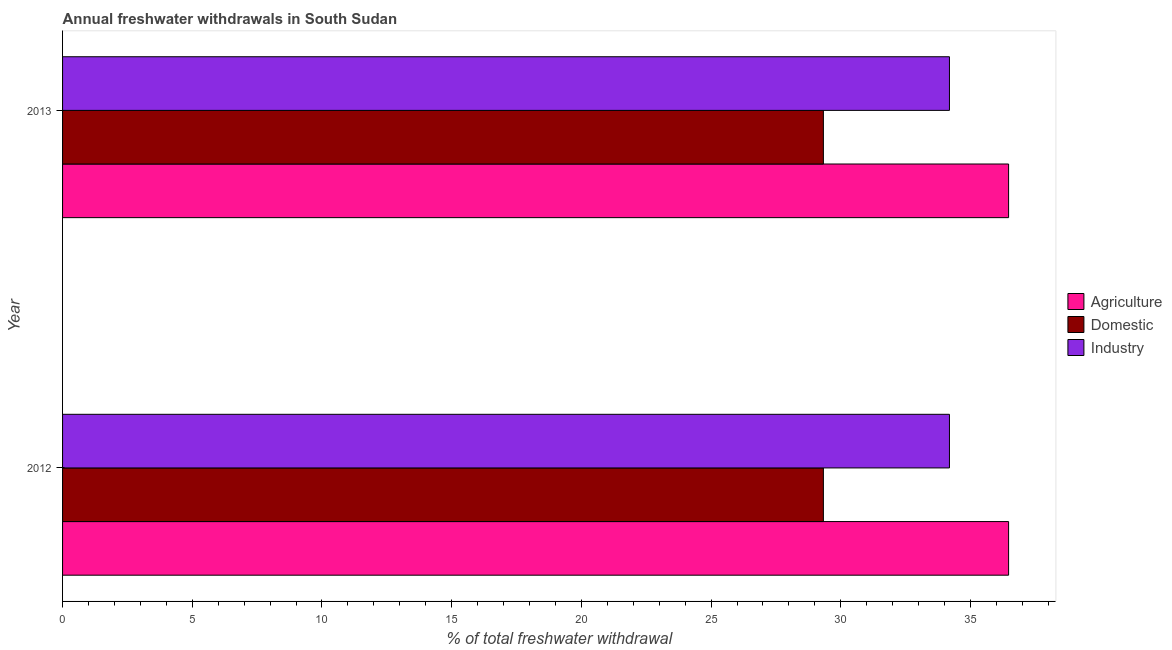How many groups of bars are there?
Offer a very short reply. 2. Are the number of bars per tick equal to the number of legend labels?
Provide a succinct answer. Yes. How many bars are there on the 1st tick from the bottom?
Your response must be concise. 3. What is the percentage of freshwater withdrawal for domestic purposes in 2013?
Make the answer very short. 29.33. Across all years, what is the maximum percentage of freshwater withdrawal for agriculture?
Keep it short and to the point. 36.47. Across all years, what is the minimum percentage of freshwater withdrawal for domestic purposes?
Ensure brevity in your answer.  29.33. What is the total percentage of freshwater withdrawal for industry in the graph?
Your answer should be compact. 68.38. What is the difference between the percentage of freshwater withdrawal for domestic purposes in 2013 and the percentage of freshwater withdrawal for industry in 2012?
Your answer should be very brief. -4.86. What is the average percentage of freshwater withdrawal for agriculture per year?
Provide a short and direct response. 36.47. In the year 2012, what is the difference between the percentage of freshwater withdrawal for domestic purposes and percentage of freshwater withdrawal for industry?
Your answer should be compact. -4.86. In how many years, is the percentage of freshwater withdrawal for domestic purposes greater than 7 %?
Your response must be concise. 2. What is the ratio of the percentage of freshwater withdrawal for agriculture in 2012 to that in 2013?
Your response must be concise. 1. Is the difference between the percentage of freshwater withdrawal for agriculture in 2012 and 2013 greater than the difference between the percentage of freshwater withdrawal for domestic purposes in 2012 and 2013?
Make the answer very short. No. In how many years, is the percentage of freshwater withdrawal for domestic purposes greater than the average percentage of freshwater withdrawal for domestic purposes taken over all years?
Your answer should be very brief. 0. What does the 1st bar from the top in 2012 represents?
Provide a short and direct response. Industry. What does the 3rd bar from the bottom in 2012 represents?
Ensure brevity in your answer.  Industry. Is it the case that in every year, the sum of the percentage of freshwater withdrawal for agriculture and percentage of freshwater withdrawal for domestic purposes is greater than the percentage of freshwater withdrawal for industry?
Give a very brief answer. Yes. How many bars are there?
Keep it short and to the point. 6. Are all the bars in the graph horizontal?
Provide a short and direct response. Yes. How many years are there in the graph?
Ensure brevity in your answer.  2. What is the difference between two consecutive major ticks on the X-axis?
Offer a very short reply. 5. Are the values on the major ticks of X-axis written in scientific E-notation?
Your answer should be very brief. No. Does the graph contain any zero values?
Provide a succinct answer. No. Where does the legend appear in the graph?
Give a very brief answer. Center right. How many legend labels are there?
Make the answer very short. 3. What is the title of the graph?
Provide a short and direct response. Annual freshwater withdrawals in South Sudan. Does "Coal" appear as one of the legend labels in the graph?
Ensure brevity in your answer.  No. What is the label or title of the X-axis?
Ensure brevity in your answer.  % of total freshwater withdrawal. What is the label or title of the Y-axis?
Keep it short and to the point. Year. What is the % of total freshwater withdrawal in Agriculture in 2012?
Offer a very short reply. 36.47. What is the % of total freshwater withdrawal of Domestic in 2012?
Provide a short and direct response. 29.33. What is the % of total freshwater withdrawal of Industry in 2012?
Offer a terse response. 34.19. What is the % of total freshwater withdrawal of Agriculture in 2013?
Offer a terse response. 36.47. What is the % of total freshwater withdrawal of Domestic in 2013?
Your response must be concise. 29.33. What is the % of total freshwater withdrawal in Industry in 2013?
Offer a terse response. 34.19. Across all years, what is the maximum % of total freshwater withdrawal of Agriculture?
Ensure brevity in your answer.  36.47. Across all years, what is the maximum % of total freshwater withdrawal of Domestic?
Your answer should be very brief. 29.33. Across all years, what is the maximum % of total freshwater withdrawal in Industry?
Give a very brief answer. 34.19. Across all years, what is the minimum % of total freshwater withdrawal of Agriculture?
Make the answer very short. 36.47. Across all years, what is the minimum % of total freshwater withdrawal of Domestic?
Make the answer very short. 29.33. Across all years, what is the minimum % of total freshwater withdrawal of Industry?
Ensure brevity in your answer.  34.19. What is the total % of total freshwater withdrawal in Agriculture in the graph?
Your answer should be compact. 72.94. What is the total % of total freshwater withdrawal of Domestic in the graph?
Your response must be concise. 58.66. What is the total % of total freshwater withdrawal of Industry in the graph?
Your answer should be very brief. 68.38. What is the difference between the % of total freshwater withdrawal of Domestic in 2012 and that in 2013?
Make the answer very short. 0. What is the difference between the % of total freshwater withdrawal of Industry in 2012 and that in 2013?
Your response must be concise. 0. What is the difference between the % of total freshwater withdrawal in Agriculture in 2012 and the % of total freshwater withdrawal in Domestic in 2013?
Your response must be concise. 7.14. What is the difference between the % of total freshwater withdrawal in Agriculture in 2012 and the % of total freshwater withdrawal in Industry in 2013?
Your answer should be compact. 2.28. What is the difference between the % of total freshwater withdrawal in Domestic in 2012 and the % of total freshwater withdrawal in Industry in 2013?
Your answer should be very brief. -4.86. What is the average % of total freshwater withdrawal in Agriculture per year?
Make the answer very short. 36.47. What is the average % of total freshwater withdrawal in Domestic per year?
Offer a terse response. 29.33. What is the average % of total freshwater withdrawal of Industry per year?
Provide a succinct answer. 34.19. In the year 2012, what is the difference between the % of total freshwater withdrawal in Agriculture and % of total freshwater withdrawal in Domestic?
Make the answer very short. 7.14. In the year 2012, what is the difference between the % of total freshwater withdrawal of Agriculture and % of total freshwater withdrawal of Industry?
Provide a short and direct response. 2.28. In the year 2012, what is the difference between the % of total freshwater withdrawal of Domestic and % of total freshwater withdrawal of Industry?
Offer a very short reply. -4.86. In the year 2013, what is the difference between the % of total freshwater withdrawal of Agriculture and % of total freshwater withdrawal of Domestic?
Give a very brief answer. 7.14. In the year 2013, what is the difference between the % of total freshwater withdrawal in Agriculture and % of total freshwater withdrawal in Industry?
Make the answer very short. 2.28. In the year 2013, what is the difference between the % of total freshwater withdrawal in Domestic and % of total freshwater withdrawal in Industry?
Keep it short and to the point. -4.86. What is the difference between the highest and the second highest % of total freshwater withdrawal of Industry?
Your answer should be very brief. 0. 